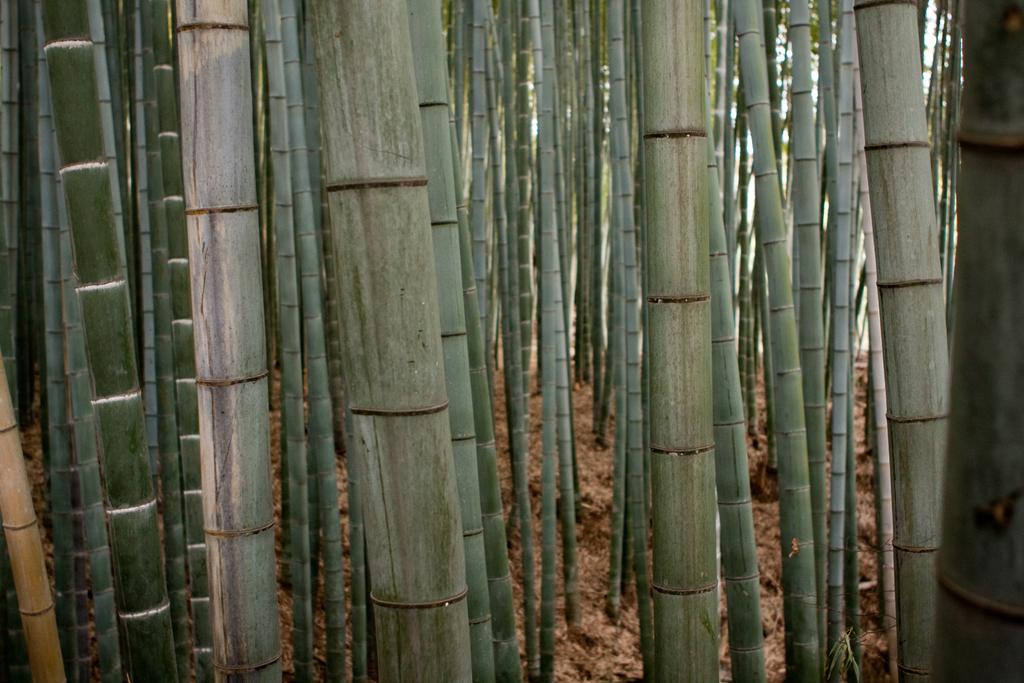What objects are on the ground in the image? There are bamboo sticks on the ground. What can be seen in the background of the image? There are trees and the sky visible in the background of the image. What time is depicted in the image? The image does not depict a specific time; it is a still image without any indication of time. 